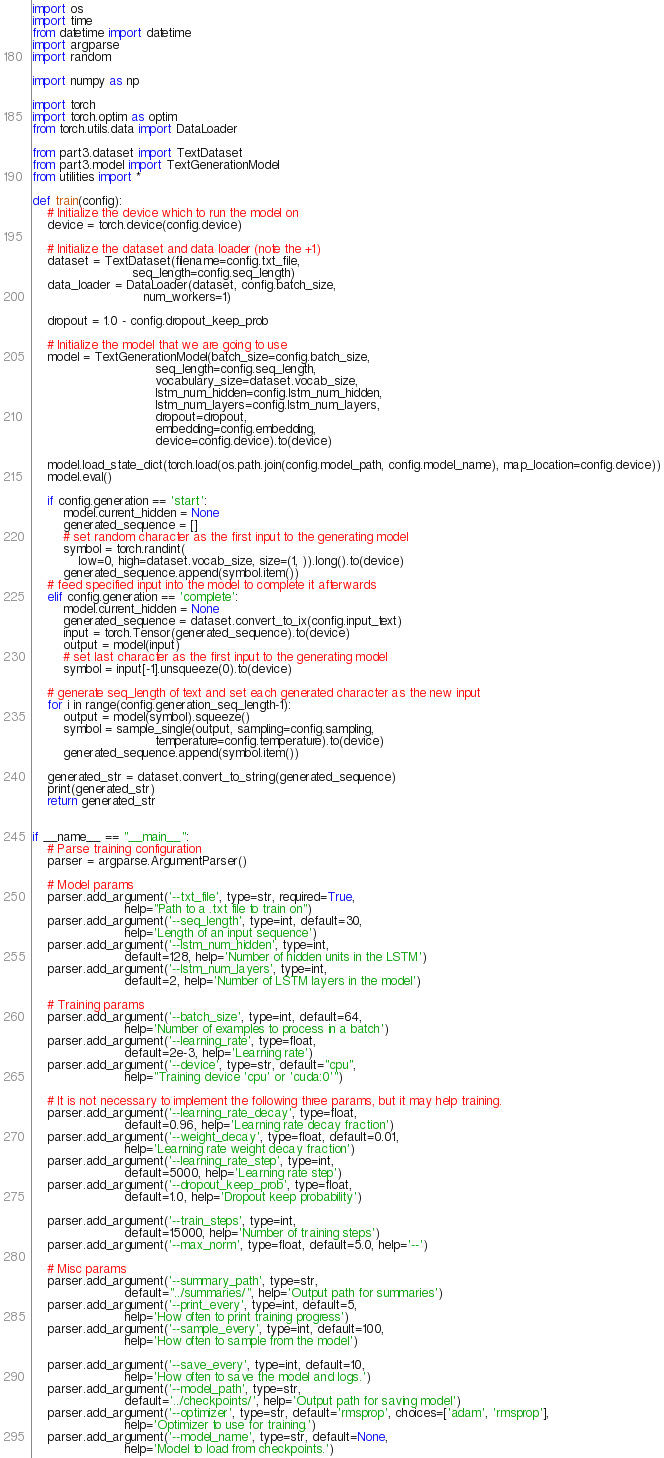Convert code to text. <code><loc_0><loc_0><loc_500><loc_500><_Python_>
import os
import time
from datetime import datetime
import argparse
import random

import numpy as np

import torch
import torch.optim as optim
from torch.utils.data import DataLoader

from part3.dataset import TextDataset
from part3.model import TextGenerationModel
from utilities import *

def train(config):
    # Initialize the device which to run the model on
    device = torch.device(config.device)

    # Initialize the dataset and data loader (note the +1)
    dataset = TextDataset(filename=config.txt_file,
                          seq_length=config.seq_length)
    data_loader = DataLoader(dataset, config.batch_size,
                             num_workers=1)

    dropout = 1.0 - config.dropout_keep_prob

    # Initialize the model that we are going to use
    model = TextGenerationModel(batch_size=config.batch_size,
                                seq_length=config.seq_length,
                                vocabulary_size=dataset.vocab_size,
                                lstm_num_hidden=config.lstm_num_hidden,
                                lstm_num_layers=config.lstm_num_layers,
                                dropout=dropout, 
                                embedding=config.embedding,
                                device=config.device).to(device)

    model.load_state_dict(torch.load(os.path.join(config.model_path, config.model_name), map_location=config.device))
    model.eval()

    if config.generation == 'start':
        model.current_hidden = None
        generated_sequence = []
        # set random character as the first input to the generating model
        symbol = torch.randint(
            low=0, high=dataset.vocab_size, size=(1, )).long().to(device)
        generated_sequence.append(symbol.item())
    # feed specified input into the model to complete it afterwards
    elif config.generation == 'complete':
        model.current_hidden = None
        generated_sequence = dataset.convert_to_ix(config.input_text)
        input = torch.Tensor(generated_sequence).to(device)
        output = model(input)
        # set last character as the first input to the generating model 
        symbol = input[-1].unsqueeze(0).to(device)
    
    # generate seq_length of text and set each generated character as the new input
    for i in range(config.generation_seq_length-1):
        output = model(symbol).squeeze()
        symbol = sample_single(output, sampling=config.sampling, 
                                temperature=config.temperature).to(device)
        generated_sequence.append(symbol.item())

    generated_str = dataset.convert_to_string(generated_sequence)
    print(generated_str)
    return generated_str
    

if __name__ == "__main__":
    # Parse training configuration
    parser = argparse.ArgumentParser()

    # Model params
    parser.add_argument('--txt_file', type=str, required=True,
                        help="Path to a .txt file to train on")
    parser.add_argument('--seq_length', type=int, default=30,
                        help='Length of an input sequence')
    parser.add_argument('--lstm_num_hidden', type=int,
                        default=128, help='Number of hidden units in the LSTM')
    parser.add_argument('--lstm_num_layers', type=int,
                        default=2, help='Number of LSTM layers in the model')

    # Training params
    parser.add_argument('--batch_size', type=int, default=64,
                        help='Number of examples to process in a batch')
    parser.add_argument('--learning_rate', type=float,
                        default=2e-3, help='Learning rate')
    parser.add_argument('--device', type=str, default="cpu",
                        help="Training device 'cpu' or 'cuda:0'")

    # It is not necessary to implement the following three params, but it may help training.
    parser.add_argument('--learning_rate_decay', type=float,
                        default=0.96, help='Learning rate decay fraction')
    parser.add_argument('--weight_decay', type=float, default=0.01,
                        help='Learning rate weight decay fraction')
    parser.add_argument('--learning_rate_step', type=int,
                        default=5000, help='Learning rate step')
    parser.add_argument('--dropout_keep_prob', type=float,
                        default=1.0, help='Dropout keep probability')

    parser.add_argument('--train_steps', type=int,
                        default=15000, help='Number of training steps')
    parser.add_argument('--max_norm', type=float, default=5.0, help='--')

    # Misc params
    parser.add_argument('--summary_path', type=str,
                        default="../summaries/", help='Output path for summaries')
    parser.add_argument('--print_every', type=int, default=5,
                        help='How often to print training progress')
    parser.add_argument('--sample_every', type=int, default=100,
                        help='How often to sample from the model')

    parser.add_argument('--save_every', type=int, default=10,
                        help='How often to save the model and logs.')
    parser.add_argument('--model_path', type=str,
                        default='../checkpoints/', help='Output path for saving model')
    parser.add_argument('--optimizer', type=str, default='rmsprop', choices=['adam', 'rmsprop'],
                        help='Optimizer to use for training.')
    parser.add_argument('--model_name', type=str, default=None,
                        help='Model to load from checkpoints.')
</code> 